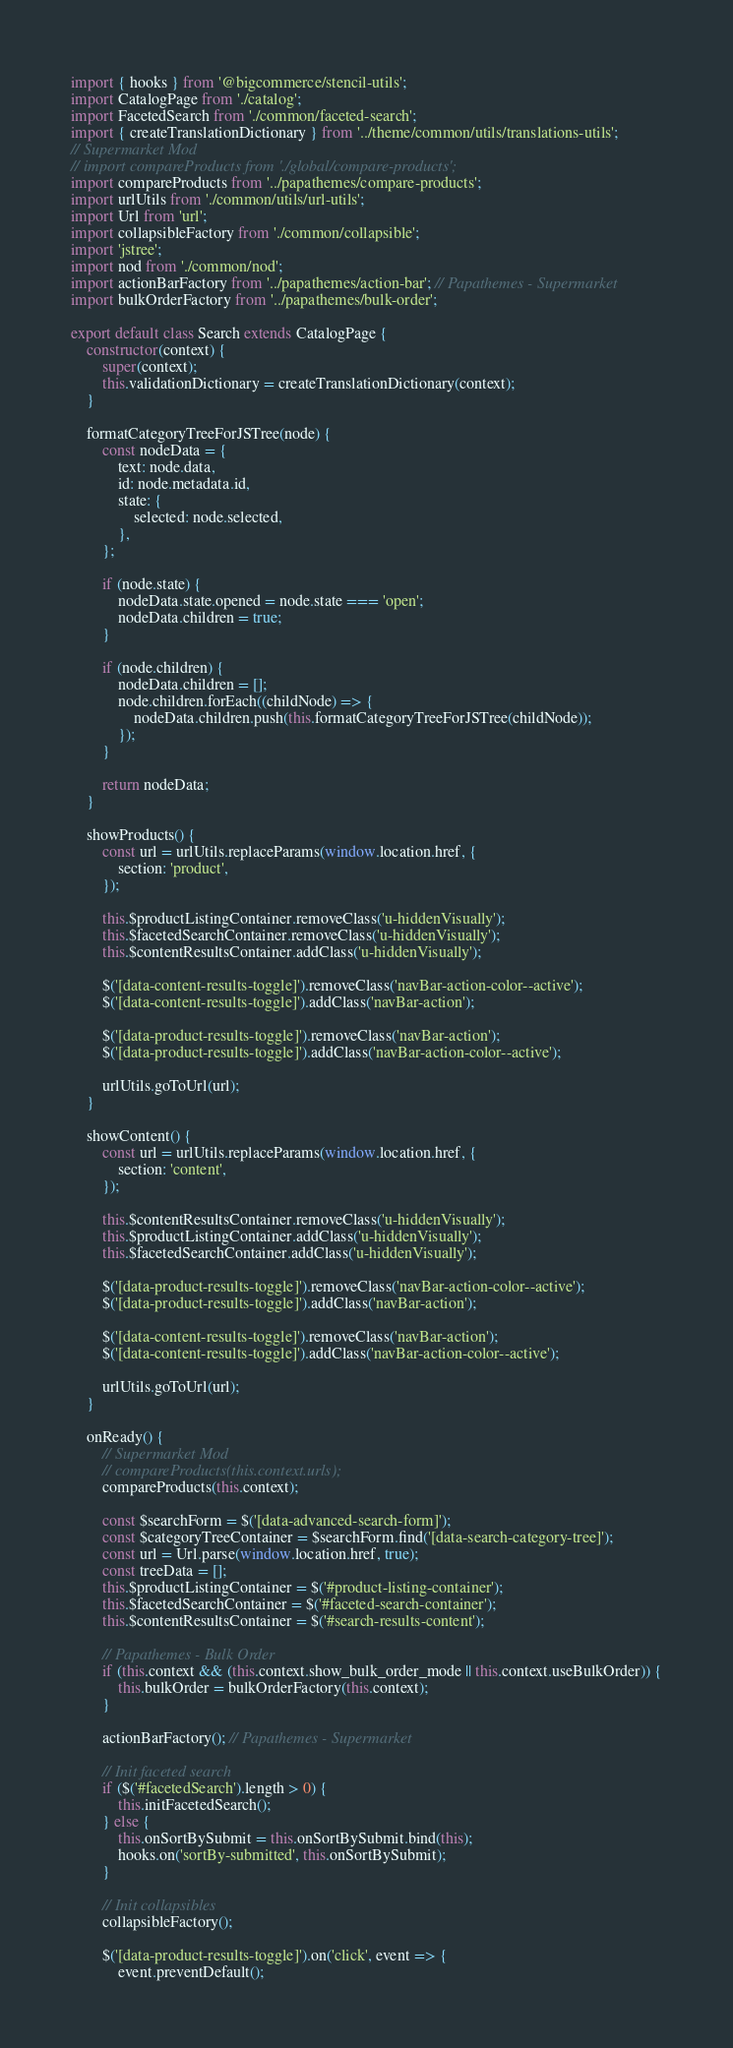Convert code to text. <code><loc_0><loc_0><loc_500><loc_500><_JavaScript_>import { hooks } from '@bigcommerce/stencil-utils';
import CatalogPage from './catalog';
import FacetedSearch from './common/faceted-search';
import { createTranslationDictionary } from '../theme/common/utils/translations-utils';
// Supermarket Mod
// import compareProducts from './global/compare-products';
import compareProducts from '../papathemes/compare-products';
import urlUtils from './common/utils/url-utils';
import Url from 'url';
import collapsibleFactory from './common/collapsible';
import 'jstree';
import nod from './common/nod';
import actionBarFactory from '../papathemes/action-bar'; // Papathemes - Supermarket
import bulkOrderFactory from '../papathemes/bulk-order';

export default class Search extends CatalogPage {
    constructor(context) {
        super(context);
        this.validationDictionary = createTranslationDictionary(context);
    }

    formatCategoryTreeForJSTree(node) {
        const nodeData = {
            text: node.data,
            id: node.metadata.id,
            state: {
                selected: node.selected,
            },
        };

        if (node.state) {
            nodeData.state.opened = node.state === 'open';
            nodeData.children = true;
        }

        if (node.children) {
            nodeData.children = [];
            node.children.forEach((childNode) => {
                nodeData.children.push(this.formatCategoryTreeForJSTree(childNode));
            });
        }

        return nodeData;
    }

    showProducts() {
        const url = urlUtils.replaceParams(window.location.href, {
            section: 'product',
        });

        this.$productListingContainer.removeClass('u-hiddenVisually');
        this.$facetedSearchContainer.removeClass('u-hiddenVisually');
        this.$contentResultsContainer.addClass('u-hiddenVisually');

        $('[data-content-results-toggle]').removeClass('navBar-action-color--active');
        $('[data-content-results-toggle]').addClass('navBar-action');

        $('[data-product-results-toggle]').removeClass('navBar-action');
        $('[data-product-results-toggle]').addClass('navBar-action-color--active');

        urlUtils.goToUrl(url);
    }

    showContent() {
        const url = urlUtils.replaceParams(window.location.href, {
            section: 'content',
        });

        this.$contentResultsContainer.removeClass('u-hiddenVisually');
        this.$productListingContainer.addClass('u-hiddenVisually');
        this.$facetedSearchContainer.addClass('u-hiddenVisually');

        $('[data-product-results-toggle]').removeClass('navBar-action-color--active');
        $('[data-product-results-toggle]').addClass('navBar-action');

        $('[data-content-results-toggle]').removeClass('navBar-action');
        $('[data-content-results-toggle]').addClass('navBar-action-color--active');

        urlUtils.goToUrl(url);
    }

    onReady() {
        // Supermarket Mod
        // compareProducts(this.context.urls);
        compareProducts(this.context);

        const $searchForm = $('[data-advanced-search-form]');
        const $categoryTreeContainer = $searchForm.find('[data-search-category-tree]');
        const url = Url.parse(window.location.href, true);
        const treeData = [];
        this.$productListingContainer = $('#product-listing-container');
        this.$facetedSearchContainer = $('#faceted-search-container');
        this.$contentResultsContainer = $('#search-results-content');

        // Papathemes - Bulk Order
        if (this.context && (this.context.show_bulk_order_mode || this.context.useBulkOrder)) {
            this.bulkOrder = bulkOrderFactory(this.context);
        }

        actionBarFactory(); // Papathemes - Supermarket

        // Init faceted search
        if ($('#facetedSearch').length > 0) {
            this.initFacetedSearch();
        } else {
            this.onSortBySubmit = this.onSortBySubmit.bind(this);
            hooks.on('sortBy-submitted', this.onSortBySubmit);
        }

        // Init collapsibles
        collapsibleFactory();

        $('[data-product-results-toggle]').on('click', event => {
            event.preventDefault();</code> 